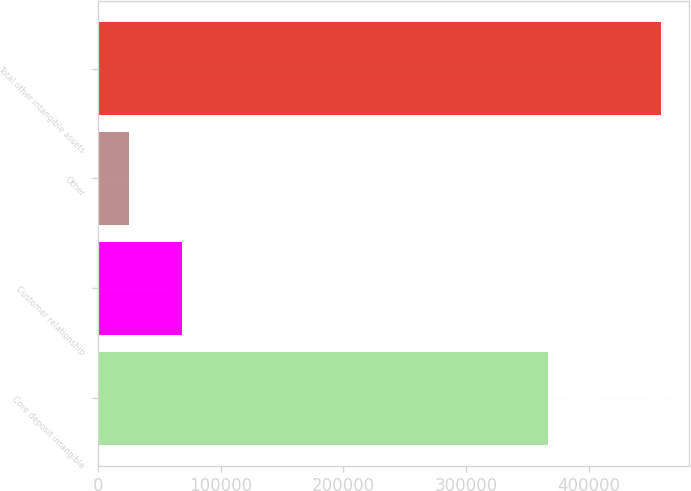Convert chart to OTSL. <chart><loc_0><loc_0><loc_500><loc_500><bar_chart><fcel>Core deposit intangible<fcel>Customer relationship<fcel>Other<fcel>Total other intangible assets<nl><fcel>366907<fcel>68374.1<fcel>25030<fcel>458471<nl></chart> 